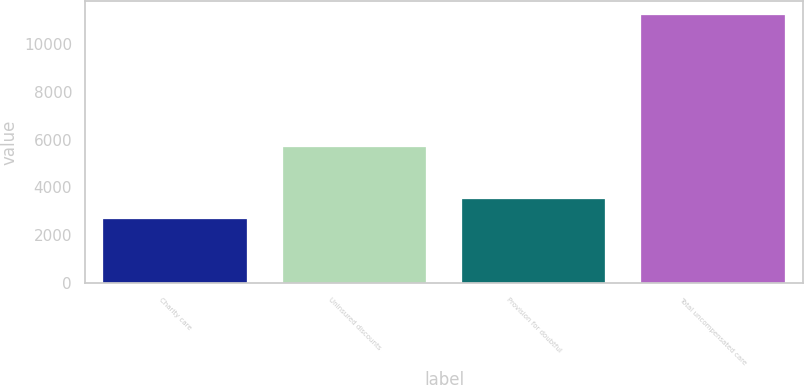Convert chart to OTSL. <chart><loc_0><loc_0><loc_500><loc_500><bar_chart><fcel>Charity care<fcel>Uninsured discounts<fcel>Provision for doubtful<fcel>Total uncompensated care<nl><fcel>2683<fcel>5707<fcel>3536.1<fcel>11214<nl></chart> 